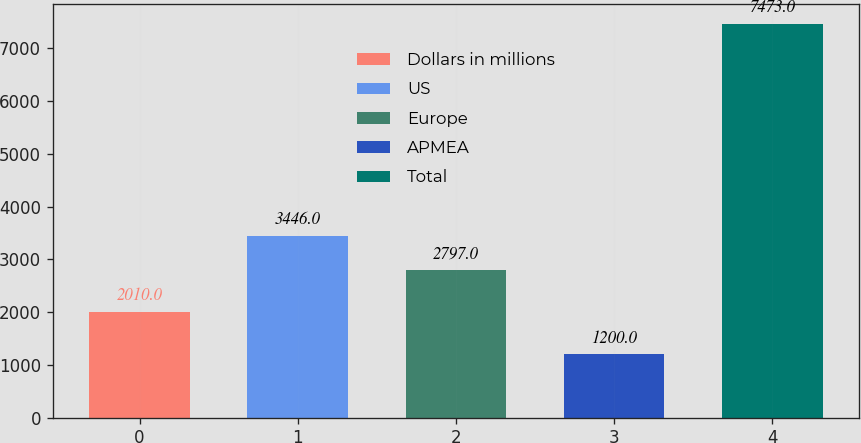Convert chart to OTSL. <chart><loc_0><loc_0><loc_500><loc_500><bar_chart><fcel>Dollars in millions<fcel>US<fcel>Europe<fcel>APMEA<fcel>Total<nl><fcel>2010<fcel>3446<fcel>2797<fcel>1200<fcel>7473<nl></chart> 